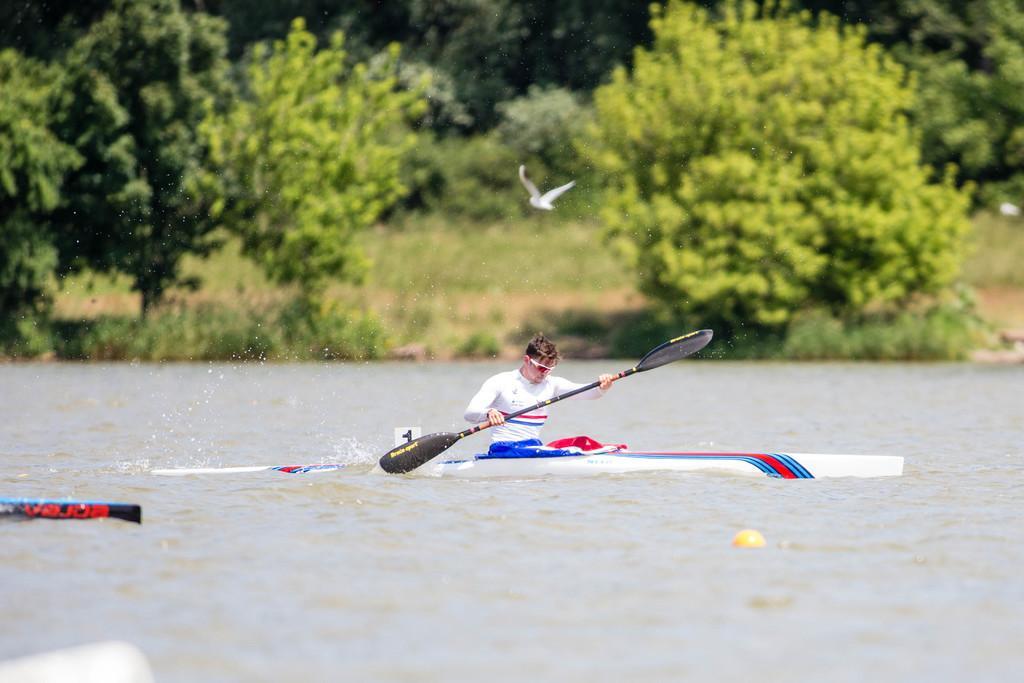How would you summarize this image in a sentence or two? In this picture we can see a man is sitting on a kayak and kayak is on the water. He is holding a paddle. Behind the man, there are trees. On the left side of the image, there is an object. There is a round shape object is floating on the water. 